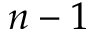Convert formula to latex. <formula><loc_0><loc_0><loc_500><loc_500>n - 1</formula> 